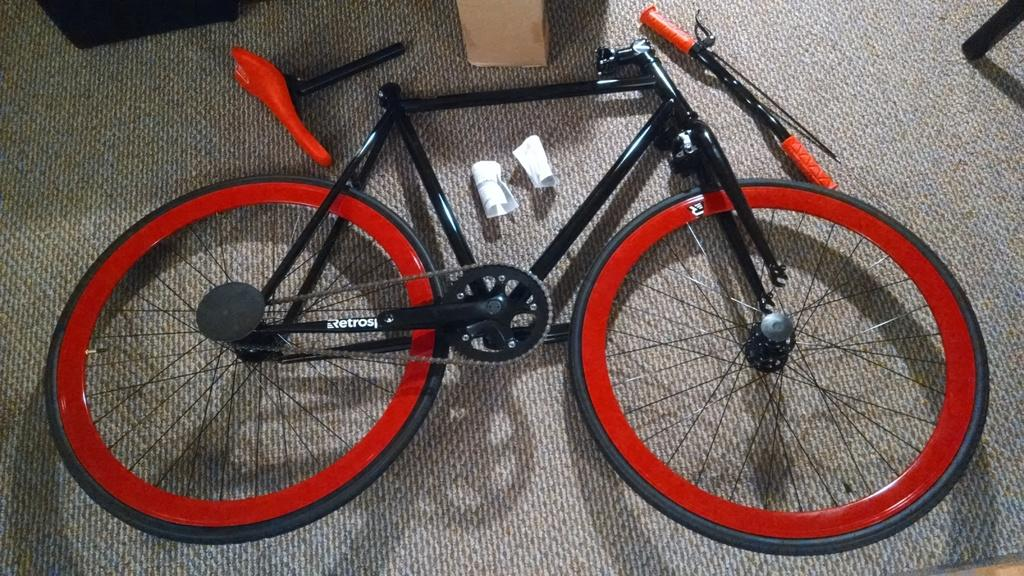What colors are featured in the color cycle on the floor? The color cycle on the floor has black and red colors. Can you describe any other objects in the image besides the color cycle? Unfortunately, there is not enough information provided about the other objects in the image. Is there any cream being served in the image? There is no mention of cream or any food items in the image. Is there a crown visible in the image? There is no crown or any royal objects mentioned in the image. 